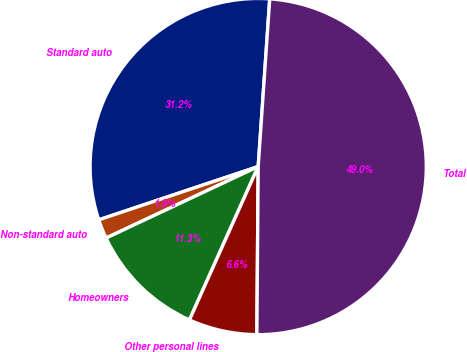<chart> <loc_0><loc_0><loc_500><loc_500><pie_chart><fcel>Standard auto<fcel>Non-standard auto<fcel>Homeowners<fcel>Other personal lines<fcel>Total<nl><fcel>31.23%<fcel>1.86%<fcel>11.3%<fcel>6.58%<fcel>49.03%<nl></chart> 